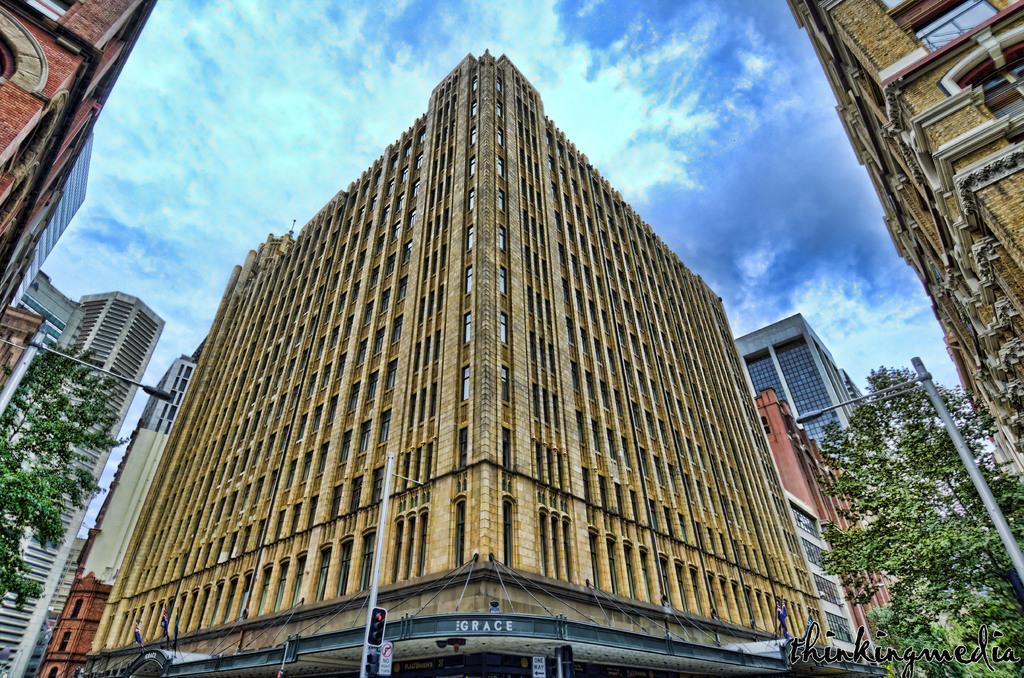Could you give a brief overview of what you see in this image? In this image there are buildings, trees, poles and the sky. 